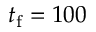Convert formula to latex. <formula><loc_0><loc_0><loc_500><loc_500>t _ { f } = 1 0 0</formula> 